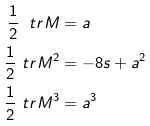Convert formula to latex. <formula><loc_0><loc_0><loc_500><loc_500>\frac { 1 } { 2 } \ t r M & = a \\ \frac { 1 } { 2 } \ t r M ^ { 2 } & = - 8 s + a ^ { 2 } \\ \frac { 1 } { 2 } \ t r { M ^ { 3 } } & = a ^ { 3 }</formula> 